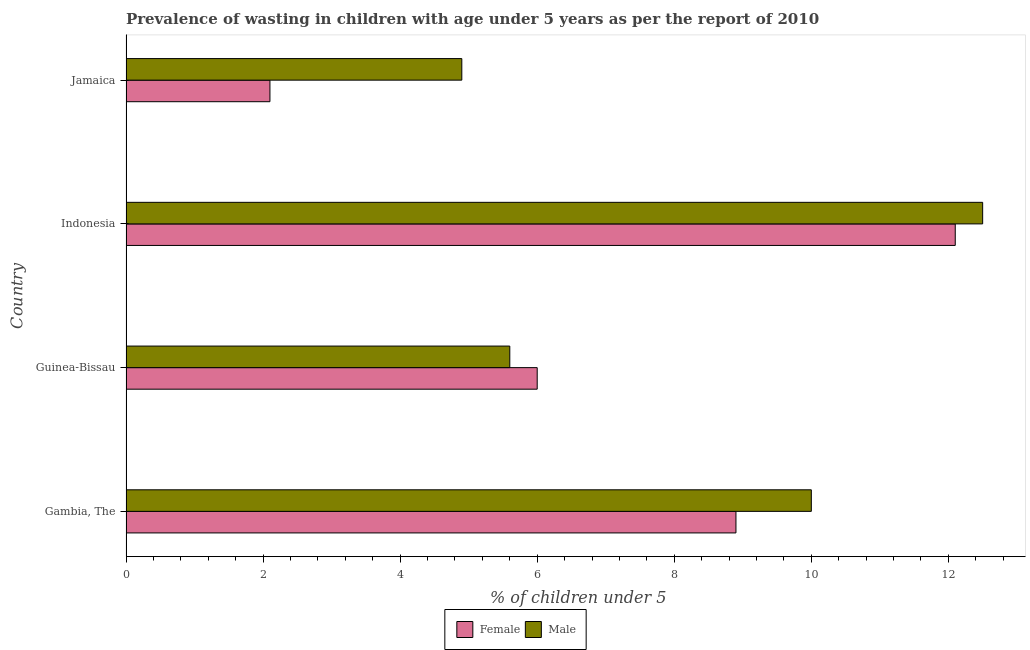Are the number of bars per tick equal to the number of legend labels?
Your answer should be compact. Yes. How many bars are there on the 4th tick from the top?
Your answer should be very brief. 2. How many bars are there on the 1st tick from the bottom?
Keep it short and to the point. 2. What is the label of the 4th group of bars from the top?
Ensure brevity in your answer.  Gambia, The. What is the percentage of undernourished female children in Indonesia?
Your answer should be very brief. 12.1. Across all countries, what is the maximum percentage of undernourished female children?
Provide a succinct answer. 12.1. Across all countries, what is the minimum percentage of undernourished male children?
Make the answer very short. 4.9. In which country was the percentage of undernourished male children minimum?
Give a very brief answer. Jamaica. What is the total percentage of undernourished female children in the graph?
Your answer should be compact. 29.1. What is the difference between the percentage of undernourished female children in Indonesia and the percentage of undernourished male children in Guinea-Bissau?
Your answer should be very brief. 6.5. What is the average percentage of undernourished female children per country?
Give a very brief answer. 7.28. In how many countries, is the percentage of undernourished female children greater than 12 %?
Make the answer very short. 1. What is the ratio of the percentage of undernourished male children in Indonesia to that in Jamaica?
Your response must be concise. 2.55. Is the difference between the percentage of undernourished male children in Gambia, The and Jamaica greater than the difference between the percentage of undernourished female children in Gambia, The and Jamaica?
Offer a terse response. No. What is the difference between the highest and the lowest percentage of undernourished male children?
Your answer should be compact. 7.6. In how many countries, is the percentage of undernourished male children greater than the average percentage of undernourished male children taken over all countries?
Offer a very short reply. 2. What does the 1st bar from the top in Gambia, The represents?
Provide a short and direct response. Male. What does the 1st bar from the bottom in Indonesia represents?
Your answer should be compact. Female. How many countries are there in the graph?
Your answer should be compact. 4. What is the difference between two consecutive major ticks on the X-axis?
Make the answer very short. 2. Does the graph contain grids?
Provide a short and direct response. No. How many legend labels are there?
Offer a very short reply. 2. How are the legend labels stacked?
Your answer should be very brief. Horizontal. What is the title of the graph?
Offer a very short reply. Prevalence of wasting in children with age under 5 years as per the report of 2010. Does "Non-solid fuel" appear as one of the legend labels in the graph?
Keep it short and to the point. No. What is the label or title of the X-axis?
Make the answer very short.  % of children under 5. What is the  % of children under 5 in Female in Gambia, The?
Your response must be concise. 8.9. What is the  % of children under 5 of Female in Guinea-Bissau?
Provide a succinct answer. 6. What is the  % of children under 5 in Male in Guinea-Bissau?
Offer a very short reply. 5.6. What is the  % of children under 5 of Female in Indonesia?
Provide a short and direct response. 12.1. What is the  % of children under 5 in Male in Indonesia?
Keep it short and to the point. 12.5. What is the  % of children under 5 in Female in Jamaica?
Ensure brevity in your answer.  2.1. What is the  % of children under 5 in Male in Jamaica?
Your response must be concise. 4.9. Across all countries, what is the maximum  % of children under 5 of Female?
Give a very brief answer. 12.1. Across all countries, what is the maximum  % of children under 5 of Male?
Make the answer very short. 12.5. Across all countries, what is the minimum  % of children under 5 in Female?
Make the answer very short. 2.1. Across all countries, what is the minimum  % of children under 5 in Male?
Ensure brevity in your answer.  4.9. What is the total  % of children under 5 of Female in the graph?
Give a very brief answer. 29.1. What is the total  % of children under 5 of Male in the graph?
Offer a very short reply. 33. What is the difference between the  % of children under 5 in Male in Gambia, The and that in Indonesia?
Your answer should be very brief. -2.5. What is the difference between the  % of children under 5 of Female in Gambia, The and that in Jamaica?
Your answer should be compact. 6.8. What is the difference between the  % of children under 5 in Female in Guinea-Bissau and that in Indonesia?
Provide a succinct answer. -6.1. What is the difference between the  % of children under 5 of Female in Indonesia and that in Jamaica?
Your answer should be compact. 10. What is the difference between the  % of children under 5 in Male in Indonesia and that in Jamaica?
Your response must be concise. 7.6. What is the difference between the  % of children under 5 in Female in Gambia, The and the  % of children under 5 in Male in Jamaica?
Give a very brief answer. 4. What is the difference between the  % of children under 5 in Female in Guinea-Bissau and the  % of children under 5 in Male in Indonesia?
Provide a succinct answer. -6.5. What is the average  % of children under 5 of Female per country?
Give a very brief answer. 7.28. What is the average  % of children under 5 of Male per country?
Ensure brevity in your answer.  8.25. What is the difference between the  % of children under 5 in Female and  % of children under 5 in Male in Guinea-Bissau?
Provide a succinct answer. 0.4. What is the difference between the  % of children under 5 in Female and  % of children under 5 in Male in Indonesia?
Provide a succinct answer. -0.4. What is the ratio of the  % of children under 5 in Female in Gambia, The to that in Guinea-Bissau?
Ensure brevity in your answer.  1.48. What is the ratio of the  % of children under 5 in Male in Gambia, The to that in Guinea-Bissau?
Provide a succinct answer. 1.79. What is the ratio of the  % of children under 5 in Female in Gambia, The to that in Indonesia?
Your answer should be compact. 0.74. What is the ratio of the  % of children under 5 of Male in Gambia, The to that in Indonesia?
Keep it short and to the point. 0.8. What is the ratio of the  % of children under 5 in Female in Gambia, The to that in Jamaica?
Your answer should be compact. 4.24. What is the ratio of the  % of children under 5 of Male in Gambia, The to that in Jamaica?
Provide a short and direct response. 2.04. What is the ratio of the  % of children under 5 of Female in Guinea-Bissau to that in Indonesia?
Give a very brief answer. 0.5. What is the ratio of the  % of children under 5 of Male in Guinea-Bissau to that in Indonesia?
Keep it short and to the point. 0.45. What is the ratio of the  % of children under 5 in Female in Guinea-Bissau to that in Jamaica?
Your answer should be compact. 2.86. What is the ratio of the  % of children under 5 in Female in Indonesia to that in Jamaica?
Offer a terse response. 5.76. What is the ratio of the  % of children under 5 of Male in Indonesia to that in Jamaica?
Make the answer very short. 2.55. What is the difference between the highest and the second highest  % of children under 5 in Female?
Offer a terse response. 3.2. What is the difference between the highest and the second highest  % of children under 5 in Male?
Offer a terse response. 2.5. What is the difference between the highest and the lowest  % of children under 5 of Female?
Your answer should be compact. 10. 